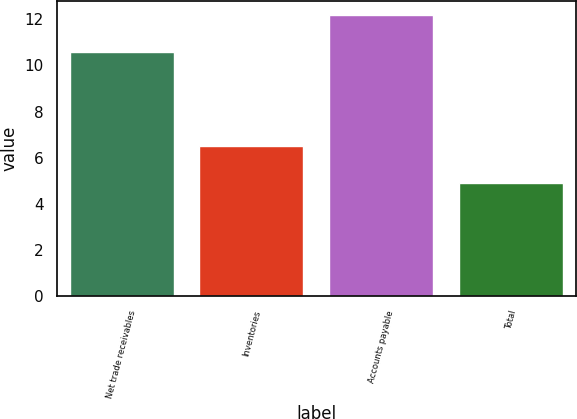Convert chart to OTSL. <chart><loc_0><loc_0><loc_500><loc_500><bar_chart><fcel>Net trade receivables<fcel>Inventories<fcel>Accounts payable<fcel>Total<nl><fcel>10.6<fcel>6.5<fcel>12.2<fcel>4.9<nl></chart> 